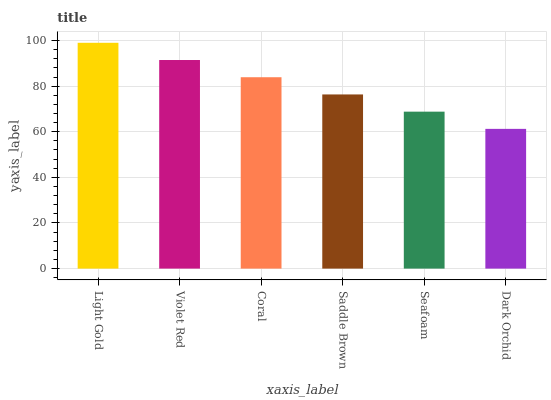Is Dark Orchid the minimum?
Answer yes or no. Yes. Is Light Gold the maximum?
Answer yes or no. Yes. Is Violet Red the minimum?
Answer yes or no. No. Is Violet Red the maximum?
Answer yes or no. No. Is Light Gold greater than Violet Red?
Answer yes or no. Yes. Is Violet Red less than Light Gold?
Answer yes or no. Yes. Is Violet Red greater than Light Gold?
Answer yes or no. No. Is Light Gold less than Violet Red?
Answer yes or no. No. Is Coral the high median?
Answer yes or no. Yes. Is Saddle Brown the low median?
Answer yes or no. Yes. Is Light Gold the high median?
Answer yes or no. No. Is Dark Orchid the low median?
Answer yes or no. No. 